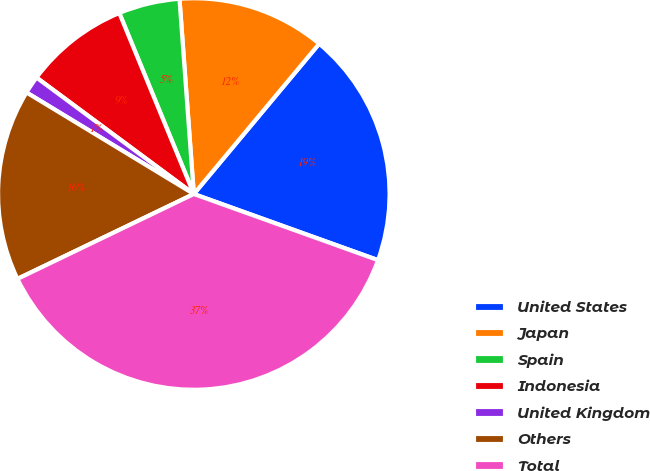<chart> <loc_0><loc_0><loc_500><loc_500><pie_chart><fcel>United States<fcel>Japan<fcel>Spain<fcel>Indonesia<fcel>United Kingdom<fcel>Others<fcel>Total<nl><fcel>19.42%<fcel>12.23%<fcel>5.05%<fcel>8.64%<fcel>1.46%<fcel>15.82%<fcel>37.37%<nl></chart> 